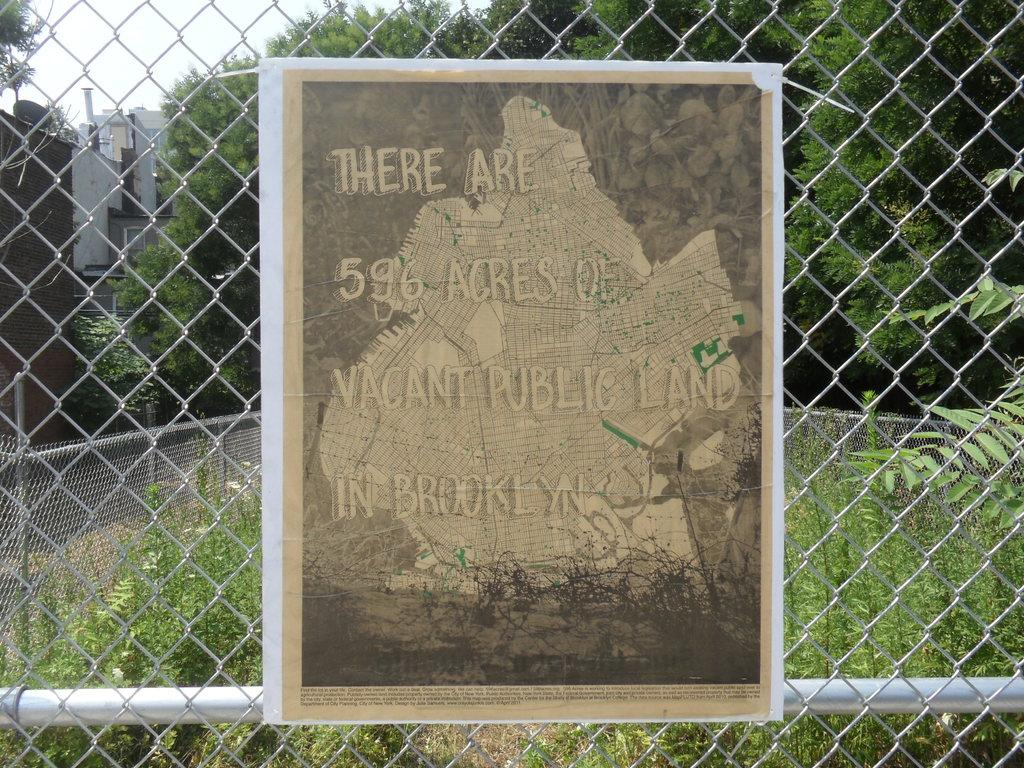What is present on the iron net in the image? There is a paper stuck to an iron net in the image. What can be seen in the background of the image? Green color trees are visible at the back side of the image. What type of brush is being used to paint the yam in the image? There is no brush or yam present in the image; it only features a paper stuck to an iron net and green color trees in the background. 